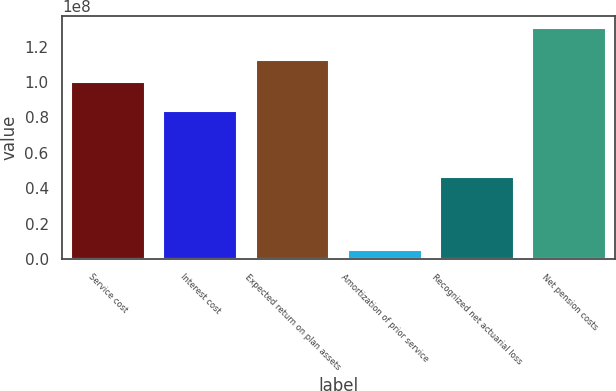<chart> <loc_0><loc_0><loc_500><loc_500><bar_chart><fcel>Service cost<fcel>Interest cost<fcel>Expected return on plan assets<fcel>Amortization of prior service<fcel>Recognized net actuarial loss<fcel>Net pension costs<nl><fcel>1.00028e+08<fcel>8.36e+07<fcel>1.12594e+08<fcel>4.934e+06<fcel>4.6204e+07<fcel>1.30592e+08<nl></chart> 